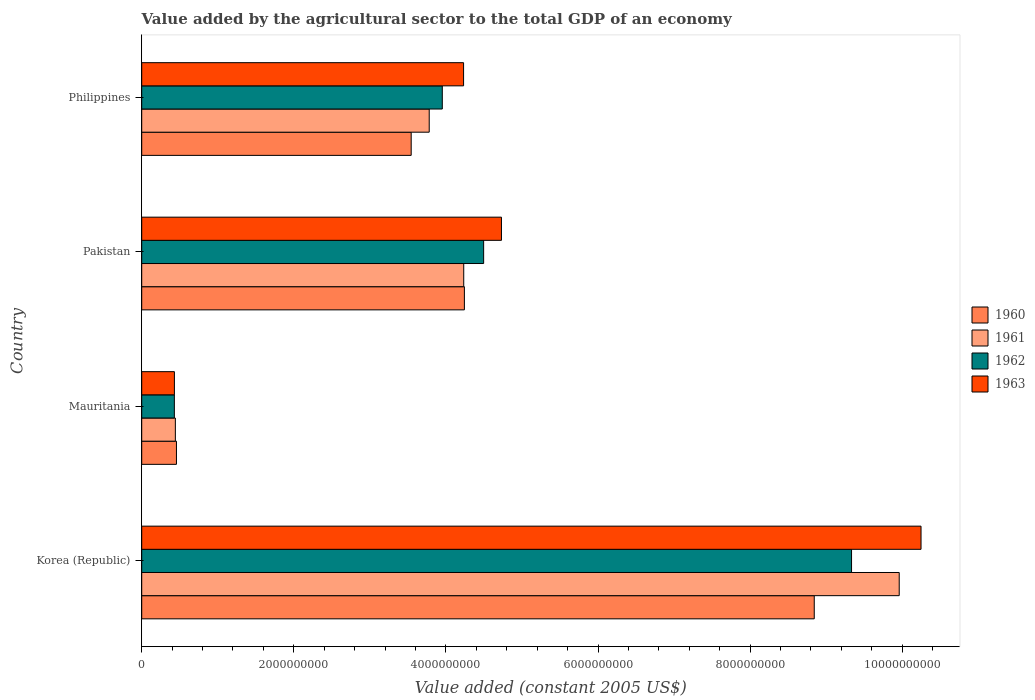How many different coloured bars are there?
Give a very brief answer. 4. How many groups of bars are there?
Your answer should be very brief. 4. Are the number of bars per tick equal to the number of legend labels?
Make the answer very short. Yes. How many bars are there on the 3rd tick from the bottom?
Your response must be concise. 4. What is the label of the 3rd group of bars from the top?
Provide a succinct answer. Mauritania. What is the value added by the agricultural sector in 1962 in Korea (Republic)?
Provide a succinct answer. 9.33e+09. Across all countries, what is the maximum value added by the agricultural sector in 1961?
Offer a terse response. 9.96e+09. Across all countries, what is the minimum value added by the agricultural sector in 1963?
Your response must be concise. 4.30e+08. In which country was the value added by the agricultural sector in 1960 minimum?
Keep it short and to the point. Mauritania. What is the total value added by the agricultural sector in 1960 in the graph?
Make the answer very short. 1.71e+1. What is the difference between the value added by the agricultural sector in 1960 in Mauritania and that in Pakistan?
Ensure brevity in your answer.  -3.79e+09. What is the difference between the value added by the agricultural sector in 1960 in Korea (Republic) and the value added by the agricultural sector in 1962 in Philippines?
Give a very brief answer. 4.89e+09. What is the average value added by the agricultural sector in 1961 per country?
Ensure brevity in your answer.  4.60e+09. What is the difference between the value added by the agricultural sector in 1962 and value added by the agricultural sector in 1963 in Mauritania?
Keep it short and to the point. -7.06e+05. What is the ratio of the value added by the agricultural sector in 1963 in Mauritania to that in Philippines?
Offer a terse response. 0.1. What is the difference between the highest and the second highest value added by the agricultural sector in 1962?
Your answer should be very brief. 4.84e+09. What is the difference between the highest and the lowest value added by the agricultural sector in 1962?
Your answer should be compact. 8.91e+09. Is the sum of the value added by the agricultural sector in 1962 in Korea (Republic) and Mauritania greater than the maximum value added by the agricultural sector in 1963 across all countries?
Your answer should be very brief. No. Is it the case that in every country, the sum of the value added by the agricultural sector in 1963 and value added by the agricultural sector in 1960 is greater than the sum of value added by the agricultural sector in 1962 and value added by the agricultural sector in 1961?
Your response must be concise. No. Is it the case that in every country, the sum of the value added by the agricultural sector in 1960 and value added by the agricultural sector in 1963 is greater than the value added by the agricultural sector in 1961?
Ensure brevity in your answer.  Yes. How many bars are there?
Keep it short and to the point. 16. How many countries are there in the graph?
Keep it short and to the point. 4. Does the graph contain any zero values?
Make the answer very short. No. How many legend labels are there?
Offer a very short reply. 4. How are the legend labels stacked?
Provide a succinct answer. Vertical. What is the title of the graph?
Offer a terse response. Value added by the agricultural sector to the total GDP of an economy. Does "2003" appear as one of the legend labels in the graph?
Make the answer very short. No. What is the label or title of the X-axis?
Your answer should be very brief. Value added (constant 2005 US$). What is the label or title of the Y-axis?
Provide a succinct answer. Country. What is the Value added (constant 2005 US$) of 1960 in Korea (Republic)?
Offer a terse response. 8.84e+09. What is the Value added (constant 2005 US$) of 1961 in Korea (Republic)?
Keep it short and to the point. 9.96e+09. What is the Value added (constant 2005 US$) of 1962 in Korea (Republic)?
Your response must be concise. 9.33e+09. What is the Value added (constant 2005 US$) in 1963 in Korea (Republic)?
Keep it short and to the point. 1.02e+1. What is the Value added (constant 2005 US$) of 1960 in Mauritania?
Provide a short and direct response. 4.57e+08. What is the Value added (constant 2005 US$) in 1961 in Mauritania?
Provide a succinct answer. 4.42e+08. What is the Value added (constant 2005 US$) of 1962 in Mauritania?
Your answer should be very brief. 4.29e+08. What is the Value added (constant 2005 US$) of 1963 in Mauritania?
Your response must be concise. 4.30e+08. What is the Value added (constant 2005 US$) of 1960 in Pakistan?
Give a very brief answer. 4.24e+09. What is the Value added (constant 2005 US$) in 1961 in Pakistan?
Your answer should be compact. 4.23e+09. What is the Value added (constant 2005 US$) of 1962 in Pakistan?
Offer a terse response. 4.50e+09. What is the Value added (constant 2005 US$) in 1963 in Pakistan?
Your answer should be very brief. 4.73e+09. What is the Value added (constant 2005 US$) in 1960 in Philippines?
Offer a very short reply. 3.54e+09. What is the Value added (constant 2005 US$) of 1961 in Philippines?
Provide a short and direct response. 3.78e+09. What is the Value added (constant 2005 US$) in 1962 in Philippines?
Ensure brevity in your answer.  3.95e+09. What is the Value added (constant 2005 US$) of 1963 in Philippines?
Your answer should be compact. 4.23e+09. Across all countries, what is the maximum Value added (constant 2005 US$) of 1960?
Provide a succinct answer. 8.84e+09. Across all countries, what is the maximum Value added (constant 2005 US$) in 1961?
Offer a very short reply. 9.96e+09. Across all countries, what is the maximum Value added (constant 2005 US$) in 1962?
Your answer should be very brief. 9.33e+09. Across all countries, what is the maximum Value added (constant 2005 US$) in 1963?
Your answer should be compact. 1.02e+1. Across all countries, what is the minimum Value added (constant 2005 US$) of 1960?
Keep it short and to the point. 4.57e+08. Across all countries, what is the minimum Value added (constant 2005 US$) in 1961?
Give a very brief answer. 4.42e+08. Across all countries, what is the minimum Value added (constant 2005 US$) in 1962?
Your answer should be very brief. 4.29e+08. Across all countries, what is the minimum Value added (constant 2005 US$) of 1963?
Offer a terse response. 4.30e+08. What is the total Value added (constant 2005 US$) of 1960 in the graph?
Your answer should be compact. 1.71e+1. What is the total Value added (constant 2005 US$) of 1961 in the graph?
Your answer should be compact. 1.84e+1. What is the total Value added (constant 2005 US$) of 1962 in the graph?
Keep it short and to the point. 1.82e+1. What is the total Value added (constant 2005 US$) in 1963 in the graph?
Your response must be concise. 1.96e+1. What is the difference between the Value added (constant 2005 US$) in 1960 in Korea (Republic) and that in Mauritania?
Your response must be concise. 8.39e+09. What is the difference between the Value added (constant 2005 US$) of 1961 in Korea (Republic) and that in Mauritania?
Provide a short and direct response. 9.52e+09. What is the difference between the Value added (constant 2005 US$) of 1962 in Korea (Republic) and that in Mauritania?
Provide a succinct answer. 8.91e+09. What is the difference between the Value added (constant 2005 US$) of 1963 in Korea (Republic) and that in Mauritania?
Your response must be concise. 9.82e+09. What is the difference between the Value added (constant 2005 US$) in 1960 in Korea (Republic) and that in Pakistan?
Provide a succinct answer. 4.60e+09. What is the difference between the Value added (constant 2005 US$) in 1961 in Korea (Republic) and that in Pakistan?
Ensure brevity in your answer.  5.73e+09. What is the difference between the Value added (constant 2005 US$) in 1962 in Korea (Republic) and that in Pakistan?
Your response must be concise. 4.84e+09. What is the difference between the Value added (constant 2005 US$) of 1963 in Korea (Republic) and that in Pakistan?
Your response must be concise. 5.52e+09. What is the difference between the Value added (constant 2005 US$) in 1960 in Korea (Republic) and that in Philippines?
Make the answer very short. 5.30e+09. What is the difference between the Value added (constant 2005 US$) in 1961 in Korea (Republic) and that in Philippines?
Give a very brief answer. 6.18e+09. What is the difference between the Value added (constant 2005 US$) of 1962 in Korea (Republic) and that in Philippines?
Offer a terse response. 5.38e+09. What is the difference between the Value added (constant 2005 US$) of 1963 in Korea (Republic) and that in Philippines?
Your response must be concise. 6.02e+09. What is the difference between the Value added (constant 2005 US$) of 1960 in Mauritania and that in Pakistan?
Give a very brief answer. -3.79e+09. What is the difference between the Value added (constant 2005 US$) of 1961 in Mauritania and that in Pakistan?
Provide a short and direct response. -3.79e+09. What is the difference between the Value added (constant 2005 US$) in 1962 in Mauritania and that in Pakistan?
Provide a succinct answer. -4.07e+09. What is the difference between the Value added (constant 2005 US$) of 1963 in Mauritania and that in Pakistan?
Offer a terse response. -4.30e+09. What is the difference between the Value added (constant 2005 US$) of 1960 in Mauritania and that in Philippines?
Ensure brevity in your answer.  -3.09e+09. What is the difference between the Value added (constant 2005 US$) in 1961 in Mauritania and that in Philippines?
Provide a short and direct response. -3.34e+09. What is the difference between the Value added (constant 2005 US$) in 1962 in Mauritania and that in Philippines?
Your response must be concise. -3.52e+09. What is the difference between the Value added (constant 2005 US$) in 1963 in Mauritania and that in Philippines?
Ensure brevity in your answer.  -3.80e+09. What is the difference between the Value added (constant 2005 US$) of 1960 in Pakistan and that in Philippines?
Your response must be concise. 7.00e+08. What is the difference between the Value added (constant 2005 US$) in 1961 in Pakistan and that in Philippines?
Ensure brevity in your answer.  4.54e+08. What is the difference between the Value added (constant 2005 US$) of 1962 in Pakistan and that in Philippines?
Keep it short and to the point. 5.44e+08. What is the difference between the Value added (constant 2005 US$) of 1963 in Pakistan and that in Philippines?
Provide a succinct answer. 4.98e+08. What is the difference between the Value added (constant 2005 US$) of 1960 in Korea (Republic) and the Value added (constant 2005 US$) of 1961 in Mauritania?
Your answer should be very brief. 8.40e+09. What is the difference between the Value added (constant 2005 US$) in 1960 in Korea (Republic) and the Value added (constant 2005 US$) in 1962 in Mauritania?
Give a very brief answer. 8.41e+09. What is the difference between the Value added (constant 2005 US$) in 1960 in Korea (Republic) and the Value added (constant 2005 US$) in 1963 in Mauritania?
Offer a very short reply. 8.41e+09. What is the difference between the Value added (constant 2005 US$) of 1961 in Korea (Republic) and the Value added (constant 2005 US$) of 1962 in Mauritania?
Offer a very short reply. 9.53e+09. What is the difference between the Value added (constant 2005 US$) in 1961 in Korea (Republic) and the Value added (constant 2005 US$) in 1963 in Mauritania?
Keep it short and to the point. 9.53e+09. What is the difference between the Value added (constant 2005 US$) of 1962 in Korea (Republic) and the Value added (constant 2005 US$) of 1963 in Mauritania?
Ensure brevity in your answer.  8.90e+09. What is the difference between the Value added (constant 2005 US$) in 1960 in Korea (Republic) and the Value added (constant 2005 US$) in 1961 in Pakistan?
Give a very brief answer. 4.61e+09. What is the difference between the Value added (constant 2005 US$) in 1960 in Korea (Republic) and the Value added (constant 2005 US$) in 1962 in Pakistan?
Your response must be concise. 4.35e+09. What is the difference between the Value added (constant 2005 US$) of 1960 in Korea (Republic) and the Value added (constant 2005 US$) of 1963 in Pakistan?
Give a very brief answer. 4.11e+09. What is the difference between the Value added (constant 2005 US$) of 1961 in Korea (Republic) and the Value added (constant 2005 US$) of 1962 in Pakistan?
Provide a succinct answer. 5.46e+09. What is the difference between the Value added (constant 2005 US$) of 1961 in Korea (Republic) and the Value added (constant 2005 US$) of 1963 in Pakistan?
Your answer should be very brief. 5.23e+09. What is the difference between the Value added (constant 2005 US$) in 1962 in Korea (Republic) and the Value added (constant 2005 US$) in 1963 in Pakistan?
Make the answer very short. 4.60e+09. What is the difference between the Value added (constant 2005 US$) in 1960 in Korea (Republic) and the Value added (constant 2005 US$) in 1961 in Philippines?
Your answer should be very brief. 5.06e+09. What is the difference between the Value added (constant 2005 US$) of 1960 in Korea (Republic) and the Value added (constant 2005 US$) of 1962 in Philippines?
Your response must be concise. 4.89e+09. What is the difference between the Value added (constant 2005 US$) in 1960 in Korea (Republic) and the Value added (constant 2005 US$) in 1963 in Philippines?
Make the answer very short. 4.61e+09. What is the difference between the Value added (constant 2005 US$) in 1961 in Korea (Republic) and the Value added (constant 2005 US$) in 1962 in Philippines?
Provide a succinct answer. 6.01e+09. What is the difference between the Value added (constant 2005 US$) in 1961 in Korea (Republic) and the Value added (constant 2005 US$) in 1963 in Philippines?
Provide a short and direct response. 5.73e+09. What is the difference between the Value added (constant 2005 US$) in 1962 in Korea (Republic) and the Value added (constant 2005 US$) in 1963 in Philippines?
Keep it short and to the point. 5.10e+09. What is the difference between the Value added (constant 2005 US$) of 1960 in Mauritania and the Value added (constant 2005 US$) of 1961 in Pakistan?
Provide a succinct answer. -3.78e+09. What is the difference between the Value added (constant 2005 US$) of 1960 in Mauritania and the Value added (constant 2005 US$) of 1962 in Pakistan?
Your response must be concise. -4.04e+09. What is the difference between the Value added (constant 2005 US$) of 1960 in Mauritania and the Value added (constant 2005 US$) of 1963 in Pakistan?
Make the answer very short. -4.27e+09. What is the difference between the Value added (constant 2005 US$) of 1961 in Mauritania and the Value added (constant 2005 US$) of 1962 in Pakistan?
Offer a very short reply. -4.05e+09. What is the difference between the Value added (constant 2005 US$) of 1961 in Mauritania and the Value added (constant 2005 US$) of 1963 in Pakistan?
Make the answer very short. -4.29e+09. What is the difference between the Value added (constant 2005 US$) in 1962 in Mauritania and the Value added (constant 2005 US$) in 1963 in Pakistan?
Ensure brevity in your answer.  -4.30e+09. What is the difference between the Value added (constant 2005 US$) in 1960 in Mauritania and the Value added (constant 2005 US$) in 1961 in Philippines?
Ensure brevity in your answer.  -3.32e+09. What is the difference between the Value added (constant 2005 US$) of 1960 in Mauritania and the Value added (constant 2005 US$) of 1962 in Philippines?
Provide a succinct answer. -3.50e+09. What is the difference between the Value added (constant 2005 US$) of 1960 in Mauritania and the Value added (constant 2005 US$) of 1963 in Philippines?
Your response must be concise. -3.78e+09. What is the difference between the Value added (constant 2005 US$) of 1961 in Mauritania and the Value added (constant 2005 US$) of 1962 in Philippines?
Ensure brevity in your answer.  -3.51e+09. What is the difference between the Value added (constant 2005 US$) of 1961 in Mauritania and the Value added (constant 2005 US$) of 1963 in Philippines?
Your response must be concise. -3.79e+09. What is the difference between the Value added (constant 2005 US$) of 1962 in Mauritania and the Value added (constant 2005 US$) of 1963 in Philippines?
Your answer should be very brief. -3.80e+09. What is the difference between the Value added (constant 2005 US$) in 1960 in Pakistan and the Value added (constant 2005 US$) in 1961 in Philippines?
Provide a succinct answer. 4.62e+08. What is the difference between the Value added (constant 2005 US$) in 1960 in Pakistan and the Value added (constant 2005 US$) in 1962 in Philippines?
Offer a very short reply. 2.90e+08. What is the difference between the Value added (constant 2005 US$) in 1960 in Pakistan and the Value added (constant 2005 US$) in 1963 in Philippines?
Provide a short and direct response. 1.07e+07. What is the difference between the Value added (constant 2005 US$) in 1961 in Pakistan and the Value added (constant 2005 US$) in 1962 in Philippines?
Make the answer very short. 2.82e+08. What is the difference between the Value added (constant 2005 US$) in 1961 in Pakistan and the Value added (constant 2005 US$) in 1963 in Philippines?
Keep it short and to the point. 2.10e+06. What is the difference between the Value added (constant 2005 US$) of 1962 in Pakistan and the Value added (constant 2005 US$) of 1963 in Philippines?
Provide a short and direct response. 2.64e+08. What is the average Value added (constant 2005 US$) of 1960 per country?
Make the answer very short. 4.27e+09. What is the average Value added (constant 2005 US$) in 1961 per country?
Give a very brief answer. 4.60e+09. What is the average Value added (constant 2005 US$) in 1962 per country?
Provide a short and direct response. 4.55e+09. What is the average Value added (constant 2005 US$) of 1963 per country?
Ensure brevity in your answer.  4.91e+09. What is the difference between the Value added (constant 2005 US$) in 1960 and Value added (constant 2005 US$) in 1961 in Korea (Republic)?
Provide a short and direct response. -1.12e+09. What is the difference between the Value added (constant 2005 US$) of 1960 and Value added (constant 2005 US$) of 1962 in Korea (Republic)?
Your response must be concise. -4.90e+08. What is the difference between the Value added (constant 2005 US$) of 1960 and Value added (constant 2005 US$) of 1963 in Korea (Republic)?
Your answer should be compact. -1.40e+09. What is the difference between the Value added (constant 2005 US$) of 1961 and Value added (constant 2005 US$) of 1962 in Korea (Republic)?
Keep it short and to the point. 6.27e+08. What is the difference between the Value added (constant 2005 US$) in 1961 and Value added (constant 2005 US$) in 1963 in Korea (Republic)?
Provide a short and direct response. -2.87e+08. What is the difference between the Value added (constant 2005 US$) in 1962 and Value added (constant 2005 US$) in 1963 in Korea (Republic)?
Keep it short and to the point. -9.14e+08. What is the difference between the Value added (constant 2005 US$) in 1960 and Value added (constant 2005 US$) in 1961 in Mauritania?
Keep it short and to the point. 1.44e+07. What is the difference between the Value added (constant 2005 US$) in 1960 and Value added (constant 2005 US$) in 1962 in Mauritania?
Provide a succinct answer. 2.75e+07. What is the difference between the Value added (constant 2005 US$) of 1960 and Value added (constant 2005 US$) of 1963 in Mauritania?
Make the answer very short. 2.68e+07. What is the difference between the Value added (constant 2005 US$) of 1961 and Value added (constant 2005 US$) of 1962 in Mauritania?
Offer a very short reply. 1.31e+07. What is the difference between the Value added (constant 2005 US$) in 1961 and Value added (constant 2005 US$) in 1963 in Mauritania?
Offer a very short reply. 1.24e+07. What is the difference between the Value added (constant 2005 US$) in 1962 and Value added (constant 2005 US$) in 1963 in Mauritania?
Make the answer very short. -7.06e+05. What is the difference between the Value added (constant 2005 US$) of 1960 and Value added (constant 2005 US$) of 1961 in Pakistan?
Provide a short and direct response. 8.56e+06. What is the difference between the Value added (constant 2005 US$) in 1960 and Value added (constant 2005 US$) in 1962 in Pakistan?
Make the answer very short. -2.53e+08. What is the difference between the Value added (constant 2005 US$) in 1960 and Value added (constant 2005 US$) in 1963 in Pakistan?
Offer a terse response. -4.87e+08. What is the difference between the Value added (constant 2005 US$) in 1961 and Value added (constant 2005 US$) in 1962 in Pakistan?
Keep it short and to the point. -2.62e+08. What is the difference between the Value added (constant 2005 US$) in 1961 and Value added (constant 2005 US$) in 1963 in Pakistan?
Offer a terse response. -4.96e+08. What is the difference between the Value added (constant 2005 US$) of 1962 and Value added (constant 2005 US$) of 1963 in Pakistan?
Ensure brevity in your answer.  -2.34e+08. What is the difference between the Value added (constant 2005 US$) in 1960 and Value added (constant 2005 US$) in 1961 in Philippines?
Your answer should be compact. -2.37e+08. What is the difference between the Value added (constant 2005 US$) of 1960 and Value added (constant 2005 US$) of 1962 in Philippines?
Offer a terse response. -4.09e+08. What is the difference between the Value added (constant 2005 US$) in 1960 and Value added (constant 2005 US$) in 1963 in Philippines?
Ensure brevity in your answer.  -6.89e+08. What is the difference between the Value added (constant 2005 US$) in 1961 and Value added (constant 2005 US$) in 1962 in Philippines?
Ensure brevity in your answer.  -1.72e+08. What is the difference between the Value added (constant 2005 US$) of 1961 and Value added (constant 2005 US$) of 1963 in Philippines?
Give a very brief answer. -4.52e+08. What is the difference between the Value added (constant 2005 US$) of 1962 and Value added (constant 2005 US$) of 1963 in Philippines?
Your answer should be compact. -2.80e+08. What is the ratio of the Value added (constant 2005 US$) of 1960 in Korea (Republic) to that in Mauritania?
Give a very brief answer. 19.37. What is the ratio of the Value added (constant 2005 US$) of 1961 in Korea (Republic) to that in Mauritania?
Provide a short and direct response. 22.52. What is the ratio of the Value added (constant 2005 US$) in 1962 in Korea (Republic) to that in Mauritania?
Your answer should be compact. 21.75. What is the ratio of the Value added (constant 2005 US$) in 1963 in Korea (Republic) to that in Mauritania?
Provide a succinct answer. 23.84. What is the ratio of the Value added (constant 2005 US$) of 1960 in Korea (Republic) to that in Pakistan?
Provide a short and direct response. 2.08. What is the ratio of the Value added (constant 2005 US$) of 1961 in Korea (Republic) to that in Pakistan?
Keep it short and to the point. 2.35. What is the ratio of the Value added (constant 2005 US$) in 1962 in Korea (Republic) to that in Pakistan?
Your response must be concise. 2.08. What is the ratio of the Value added (constant 2005 US$) of 1963 in Korea (Republic) to that in Pakistan?
Give a very brief answer. 2.17. What is the ratio of the Value added (constant 2005 US$) of 1960 in Korea (Republic) to that in Philippines?
Your response must be concise. 2.5. What is the ratio of the Value added (constant 2005 US$) of 1961 in Korea (Republic) to that in Philippines?
Offer a very short reply. 2.63. What is the ratio of the Value added (constant 2005 US$) of 1962 in Korea (Republic) to that in Philippines?
Keep it short and to the point. 2.36. What is the ratio of the Value added (constant 2005 US$) in 1963 in Korea (Republic) to that in Philippines?
Make the answer very short. 2.42. What is the ratio of the Value added (constant 2005 US$) in 1960 in Mauritania to that in Pakistan?
Your answer should be very brief. 0.11. What is the ratio of the Value added (constant 2005 US$) in 1961 in Mauritania to that in Pakistan?
Provide a short and direct response. 0.1. What is the ratio of the Value added (constant 2005 US$) of 1962 in Mauritania to that in Pakistan?
Provide a short and direct response. 0.1. What is the ratio of the Value added (constant 2005 US$) of 1963 in Mauritania to that in Pakistan?
Provide a short and direct response. 0.09. What is the ratio of the Value added (constant 2005 US$) in 1960 in Mauritania to that in Philippines?
Provide a short and direct response. 0.13. What is the ratio of the Value added (constant 2005 US$) of 1961 in Mauritania to that in Philippines?
Ensure brevity in your answer.  0.12. What is the ratio of the Value added (constant 2005 US$) of 1962 in Mauritania to that in Philippines?
Provide a short and direct response. 0.11. What is the ratio of the Value added (constant 2005 US$) in 1963 in Mauritania to that in Philippines?
Offer a terse response. 0.1. What is the ratio of the Value added (constant 2005 US$) in 1960 in Pakistan to that in Philippines?
Your response must be concise. 1.2. What is the ratio of the Value added (constant 2005 US$) in 1961 in Pakistan to that in Philippines?
Offer a very short reply. 1.12. What is the ratio of the Value added (constant 2005 US$) of 1962 in Pakistan to that in Philippines?
Provide a short and direct response. 1.14. What is the ratio of the Value added (constant 2005 US$) of 1963 in Pakistan to that in Philippines?
Provide a succinct answer. 1.12. What is the difference between the highest and the second highest Value added (constant 2005 US$) in 1960?
Make the answer very short. 4.60e+09. What is the difference between the highest and the second highest Value added (constant 2005 US$) in 1961?
Make the answer very short. 5.73e+09. What is the difference between the highest and the second highest Value added (constant 2005 US$) of 1962?
Provide a succinct answer. 4.84e+09. What is the difference between the highest and the second highest Value added (constant 2005 US$) in 1963?
Offer a very short reply. 5.52e+09. What is the difference between the highest and the lowest Value added (constant 2005 US$) of 1960?
Provide a short and direct response. 8.39e+09. What is the difference between the highest and the lowest Value added (constant 2005 US$) in 1961?
Keep it short and to the point. 9.52e+09. What is the difference between the highest and the lowest Value added (constant 2005 US$) of 1962?
Offer a very short reply. 8.91e+09. What is the difference between the highest and the lowest Value added (constant 2005 US$) of 1963?
Your answer should be compact. 9.82e+09. 